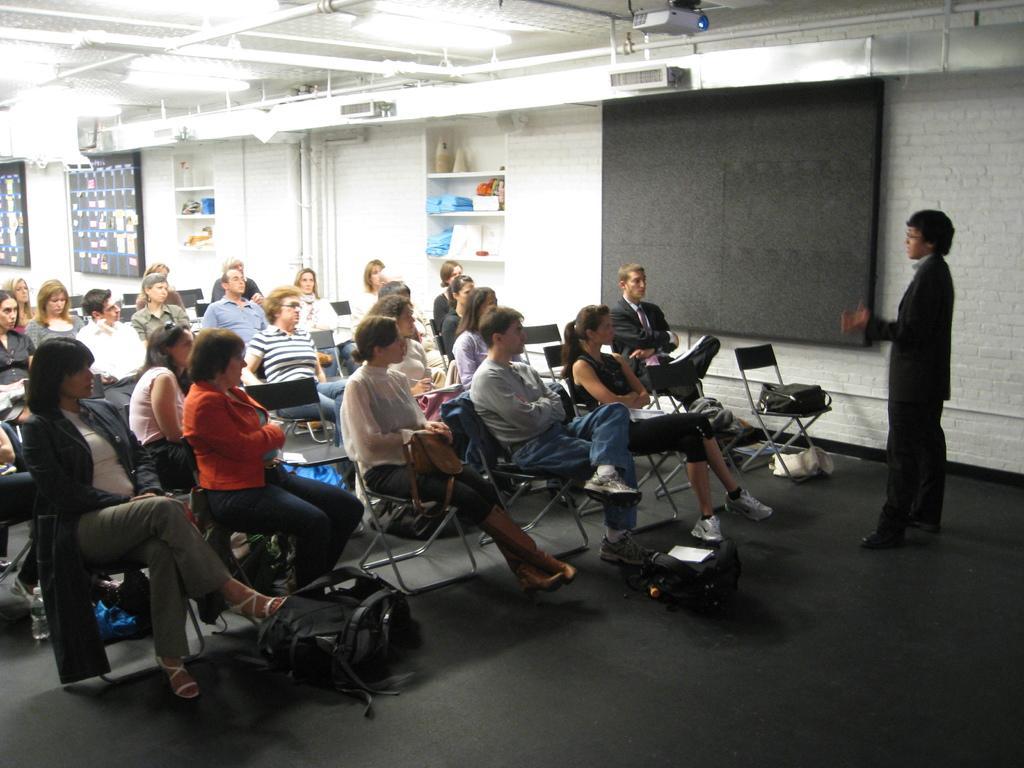Could you give a brief overview of what you see in this image? In this picture there is a group of person sitting on a chair except a woman who is standing on a right side. On the right there is a white brick wall and a black board. On the top there is a projector and a pipe lines. On the left there is a women who is wearing a jacket, in front of her there is a bag which is on the floor. There is a shelves. 